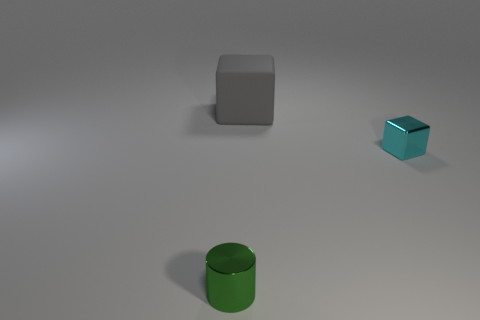Add 3 yellow matte things. How many objects exist? 6 Subtract all cubes. How many objects are left? 1 Subtract 0 brown cylinders. How many objects are left? 3 Subtract all tiny cyan objects. Subtract all cyan metallic objects. How many objects are left? 1 Add 3 big gray rubber cubes. How many big gray rubber cubes are left? 4 Add 1 small green things. How many small green things exist? 2 